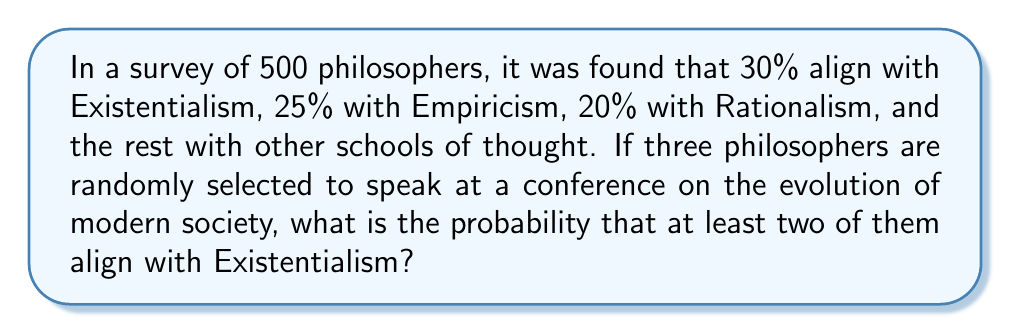Solve this math problem. Let's approach this step-by-step:

1) First, we need to calculate the probability of selecting an Existentialist philosopher:
   $P(E) = 0.30$

2) The probability of not selecting an Existentialist is:
   $P(\text{not E}) = 1 - 0.30 = 0.70$

3) Now, we need to calculate the probability of at least two out of three being Existentialists. It's easier to calculate the complement of this: the probability of 0 or 1 Existentialist, and then subtract from 1.

4) Probability of 0 Existentialists:
   $P(0E) = 0.70 \times 0.70 \times 0.70 = 0.70^3 = 0.343$

5) Probability of exactly 1 Existentialist:
   $P(1E) = \binom{3}{1} \times 0.30 \times 0.70 \times 0.70 = 3 \times 0.30 \times 0.70^2 = 0.441$

6) Probability of 0 or 1 Existentialist:
   $P(0E \text{ or } 1E) = 0.343 + 0.441 = 0.784$

7) Therefore, the probability of at least 2 Existentialists:
   $P(\text{at least 2E}) = 1 - P(0E \text{ or } 1E) = 1 - 0.784 = 0.216$

8) Rounded to three decimal places: 0.216
Answer: 0.216 